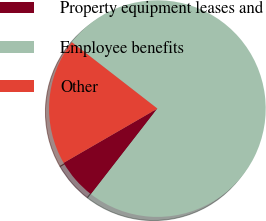<chart> <loc_0><loc_0><loc_500><loc_500><pie_chart><fcel>Property equipment leases and<fcel>Employee benefits<fcel>Other<nl><fcel>6.15%<fcel>75.0%<fcel>18.85%<nl></chart> 